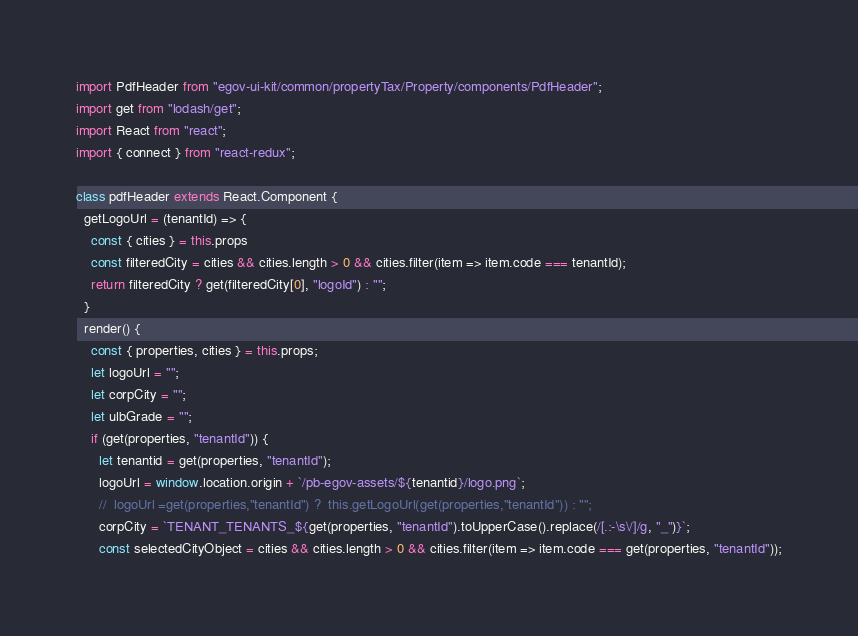<code> <loc_0><loc_0><loc_500><loc_500><_JavaScript_>import PdfHeader from "egov-ui-kit/common/propertyTax/Property/components/PdfHeader";
import get from "lodash/get";
import React from "react";
import { connect } from "react-redux";

class pdfHeader extends React.Component {
  getLogoUrl = (tenantId) => {
    const { cities } = this.props
    const filteredCity = cities && cities.length > 0 && cities.filter(item => item.code === tenantId);
    return filteredCity ? get(filteredCity[0], "logoId") : "";
  }
  render() {
    const { properties, cities } = this.props;
    let logoUrl = "";
    let corpCity = "";
    let ulbGrade = "";
    if (get(properties, "tenantId")) {
      let tenantid = get(properties, "tenantId");
      logoUrl = window.location.origin + `/pb-egov-assets/${tenantid}/logo.png`;
      //  logoUrl =get(properties,"tenantId") ?  this.getLogoUrl(get(properties,"tenantId")) : "";
      corpCity = `TENANT_TENANTS_${get(properties, "tenantId").toUpperCase().replace(/[.:-\s\/]/g, "_")}`;
      const selectedCityObject = cities && cities.length > 0 && cities.filter(item => item.code === get(properties, "tenantId"));</code> 